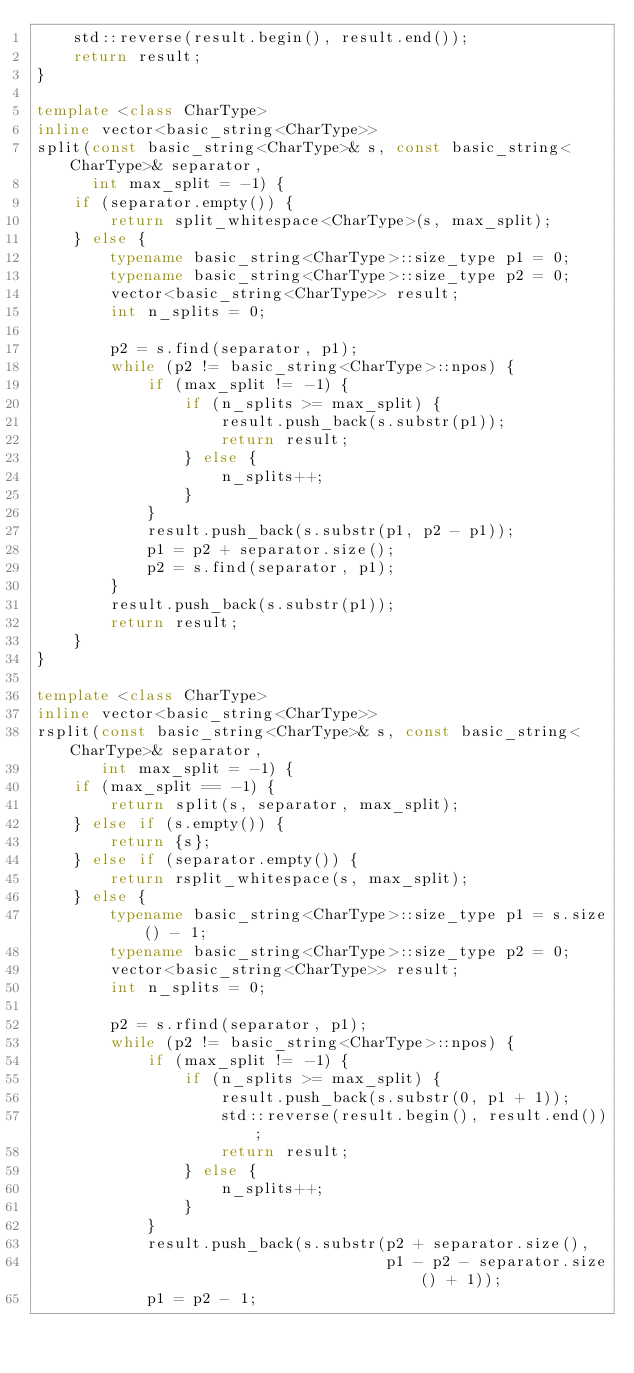Convert code to text. <code><loc_0><loc_0><loc_500><loc_500><_C++_>    std::reverse(result.begin(), result.end());
    return result;
}

template <class CharType>
inline vector<basic_string<CharType>>
split(const basic_string<CharType>& s, const basic_string<CharType>& separator,
      int max_split = -1) {
    if (separator.empty()) {
        return split_whitespace<CharType>(s, max_split);
    } else {
        typename basic_string<CharType>::size_type p1 = 0;
        typename basic_string<CharType>::size_type p2 = 0;
        vector<basic_string<CharType>> result;
        int n_splits = 0;

        p2 = s.find(separator, p1);
        while (p2 != basic_string<CharType>::npos) {
            if (max_split != -1) {
                if (n_splits >= max_split) {
                    result.push_back(s.substr(p1));
                    return result;
                } else {
                    n_splits++;
                }
            }
            result.push_back(s.substr(p1, p2 - p1));
            p1 = p2 + separator.size();
            p2 = s.find(separator, p1);
        }
        result.push_back(s.substr(p1));
        return result;
    }
}

template <class CharType>
inline vector<basic_string<CharType>>
rsplit(const basic_string<CharType>& s, const basic_string<CharType>& separator,
       int max_split = -1) {
    if (max_split == -1) {
        return split(s, separator, max_split);
    } else if (s.empty()) {
        return {s};
    } else if (separator.empty()) {
        return rsplit_whitespace(s, max_split);
    } else {
        typename basic_string<CharType>::size_type p1 = s.size() - 1;
        typename basic_string<CharType>::size_type p2 = 0;
        vector<basic_string<CharType>> result;
        int n_splits = 0;

        p2 = s.rfind(separator, p1);
        while (p2 != basic_string<CharType>::npos) {
            if (max_split != -1) {
                if (n_splits >= max_split) {
                    result.push_back(s.substr(0, p1 + 1));
                    std::reverse(result.begin(), result.end());
                    return result;
                } else {
                    n_splits++;
                }
            }
            result.push_back(s.substr(p2 + separator.size(),
                                      p1 - p2 - separator.size() + 1));
            p1 = p2 - 1;</code> 